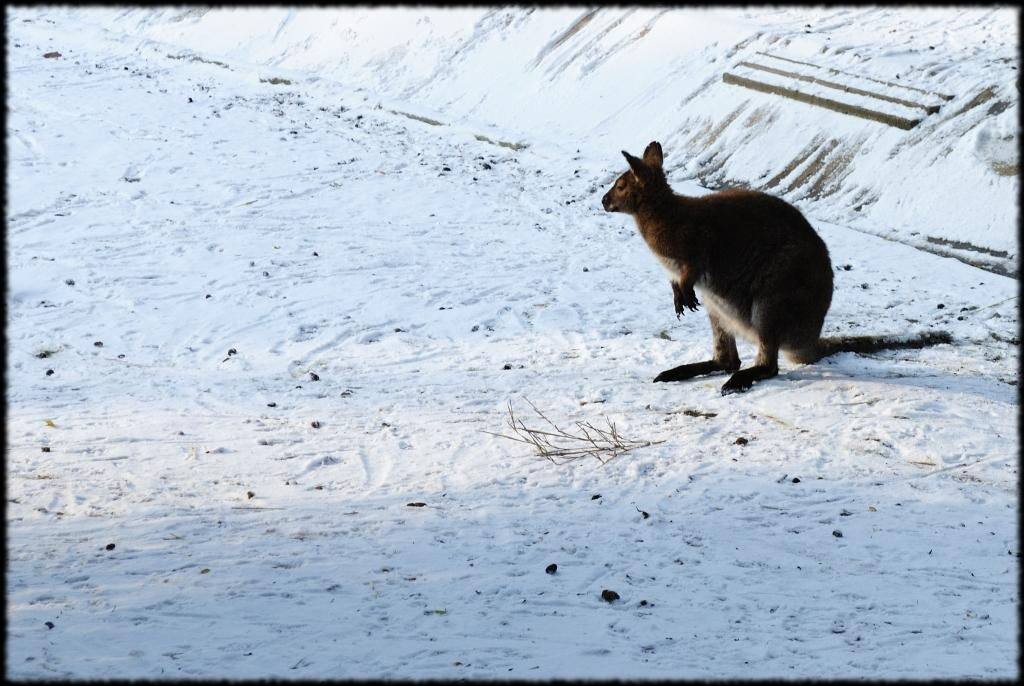What animal is located on the right side of the image? There is a kangaroo on the right side of the image. What type of terrain is depicted at the bottom of the image? There is sand at the bottom of the image. What weather condition can be observed in the background of the image? There is snow visible in the background of the image. What type of reaction does the kangaroo have to the doctor in the image? There is no doctor present in the image, so it is not possible to determine the kangaroo's reaction to a doctor. 